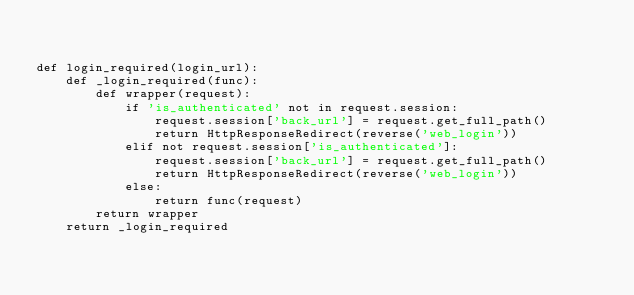<code> <loc_0><loc_0><loc_500><loc_500><_Python_>

def login_required(login_url):
    def _login_required(func):
        def wrapper(request):
            if 'is_authenticated' not in request.session:
                request.session['back_url'] = request.get_full_path()
                return HttpResponseRedirect(reverse('web_login'))
            elif not request.session['is_authenticated']:
                request.session['back_url'] = request.get_full_path()
                return HttpResponseRedirect(reverse('web_login'))
            else:
                return func(request)
        return wrapper
    return _login_required

</code> 